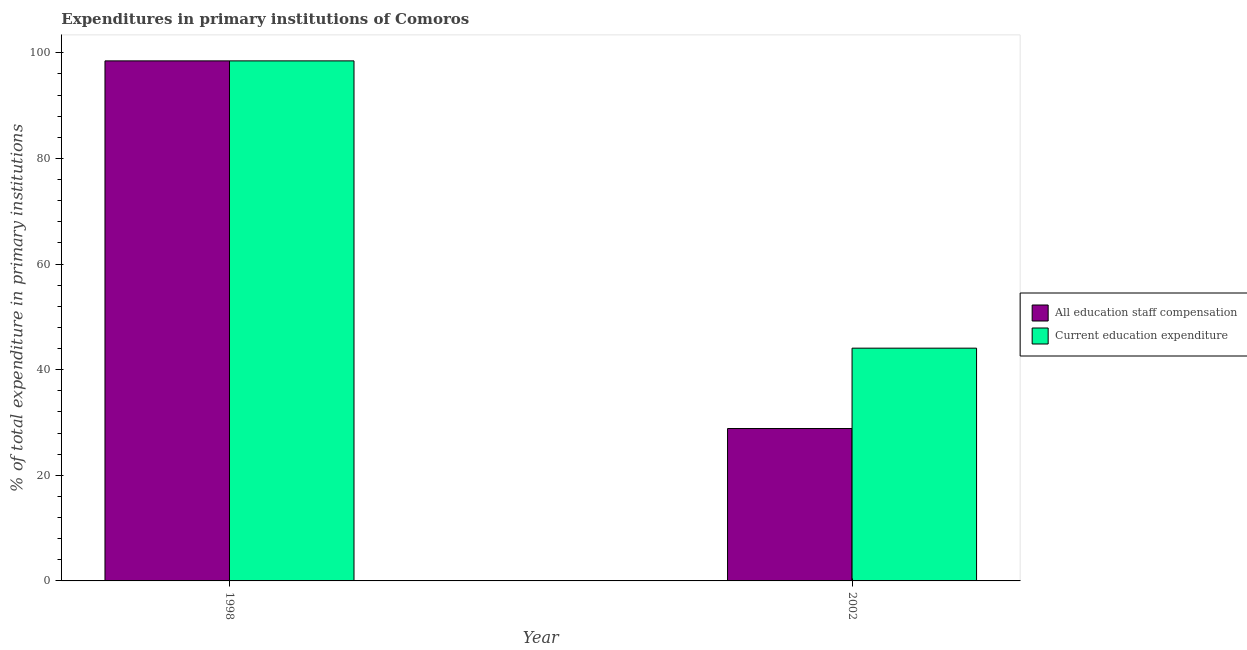How many groups of bars are there?
Keep it short and to the point. 2. Are the number of bars per tick equal to the number of legend labels?
Ensure brevity in your answer.  Yes. How many bars are there on the 2nd tick from the left?
Offer a very short reply. 2. How many bars are there on the 1st tick from the right?
Give a very brief answer. 2. What is the label of the 1st group of bars from the left?
Ensure brevity in your answer.  1998. What is the expenditure in education in 2002?
Provide a succinct answer. 44.07. Across all years, what is the maximum expenditure in staff compensation?
Offer a very short reply. 98.48. Across all years, what is the minimum expenditure in education?
Your answer should be compact. 44.07. What is the total expenditure in staff compensation in the graph?
Ensure brevity in your answer.  127.34. What is the difference between the expenditure in staff compensation in 1998 and that in 2002?
Offer a very short reply. 69.62. What is the difference between the expenditure in education in 1998 and the expenditure in staff compensation in 2002?
Ensure brevity in your answer.  54.4. What is the average expenditure in education per year?
Give a very brief answer. 71.28. In the year 1998, what is the difference between the expenditure in staff compensation and expenditure in education?
Your answer should be very brief. 0. What is the ratio of the expenditure in education in 1998 to that in 2002?
Keep it short and to the point. 2.23. What does the 1st bar from the left in 1998 represents?
Your answer should be compact. All education staff compensation. What does the 1st bar from the right in 1998 represents?
Give a very brief answer. Current education expenditure. How many years are there in the graph?
Your response must be concise. 2. Does the graph contain any zero values?
Ensure brevity in your answer.  No. Does the graph contain grids?
Your response must be concise. No. Where does the legend appear in the graph?
Make the answer very short. Center right. How many legend labels are there?
Make the answer very short. 2. How are the legend labels stacked?
Give a very brief answer. Vertical. What is the title of the graph?
Make the answer very short. Expenditures in primary institutions of Comoros. What is the label or title of the Y-axis?
Your response must be concise. % of total expenditure in primary institutions. What is the % of total expenditure in primary institutions of All education staff compensation in 1998?
Offer a very short reply. 98.48. What is the % of total expenditure in primary institutions of Current education expenditure in 1998?
Provide a short and direct response. 98.48. What is the % of total expenditure in primary institutions of All education staff compensation in 2002?
Your answer should be very brief. 28.86. What is the % of total expenditure in primary institutions in Current education expenditure in 2002?
Provide a short and direct response. 44.07. Across all years, what is the maximum % of total expenditure in primary institutions of All education staff compensation?
Make the answer very short. 98.48. Across all years, what is the maximum % of total expenditure in primary institutions in Current education expenditure?
Make the answer very short. 98.48. Across all years, what is the minimum % of total expenditure in primary institutions of All education staff compensation?
Offer a terse response. 28.86. Across all years, what is the minimum % of total expenditure in primary institutions in Current education expenditure?
Keep it short and to the point. 44.07. What is the total % of total expenditure in primary institutions of All education staff compensation in the graph?
Provide a short and direct response. 127.34. What is the total % of total expenditure in primary institutions in Current education expenditure in the graph?
Ensure brevity in your answer.  142.55. What is the difference between the % of total expenditure in primary institutions of All education staff compensation in 1998 and that in 2002?
Your response must be concise. 69.62. What is the difference between the % of total expenditure in primary institutions of Current education expenditure in 1998 and that in 2002?
Make the answer very short. 54.4. What is the difference between the % of total expenditure in primary institutions in All education staff compensation in 1998 and the % of total expenditure in primary institutions in Current education expenditure in 2002?
Give a very brief answer. 54.4. What is the average % of total expenditure in primary institutions of All education staff compensation per year?
Provide a succinct answer. 63.67. What is the average % of total expenditure in primary institutions of Current education expenditure per year?
Keep it short and to the point. 71.28. In the year 2002, what is the difference between the % of total expenditure in primary institutions of All education staff compensation and % of total expenditure in primary institutions of Current education expenditure?
Provide a short and direct response. -15.22. What is the ratio of the % of total expenditure in primary institutions in All education staff compensation in 1998 to that in 2002?
Provide a succinct answer. 3.41. What is the ratio of the % of total expenditure in primary institutions of Current education expenditure in 1998 to that in 2002?
Offer a very short reply. 2.23. What is the difference between the highest and the second highest % of total expenditure in primary institutions in All education staff compensation?
Provide a short and direct response. 69.62. What is the difference between the highest and the second highest % of total expenditure in primary institutions in Current education expenditure?
Ensure brevity in your answer.  54.4. What is the difference between the highest and the lowest % of total expenditure in primary institutions in All education staff compensation?
Your answer should be compact. 69.62. What is the difference between the highest and the lowest % of total expenditure in primary institutions in Current education expenditure?
Provide a succinct answer. 54.4. 